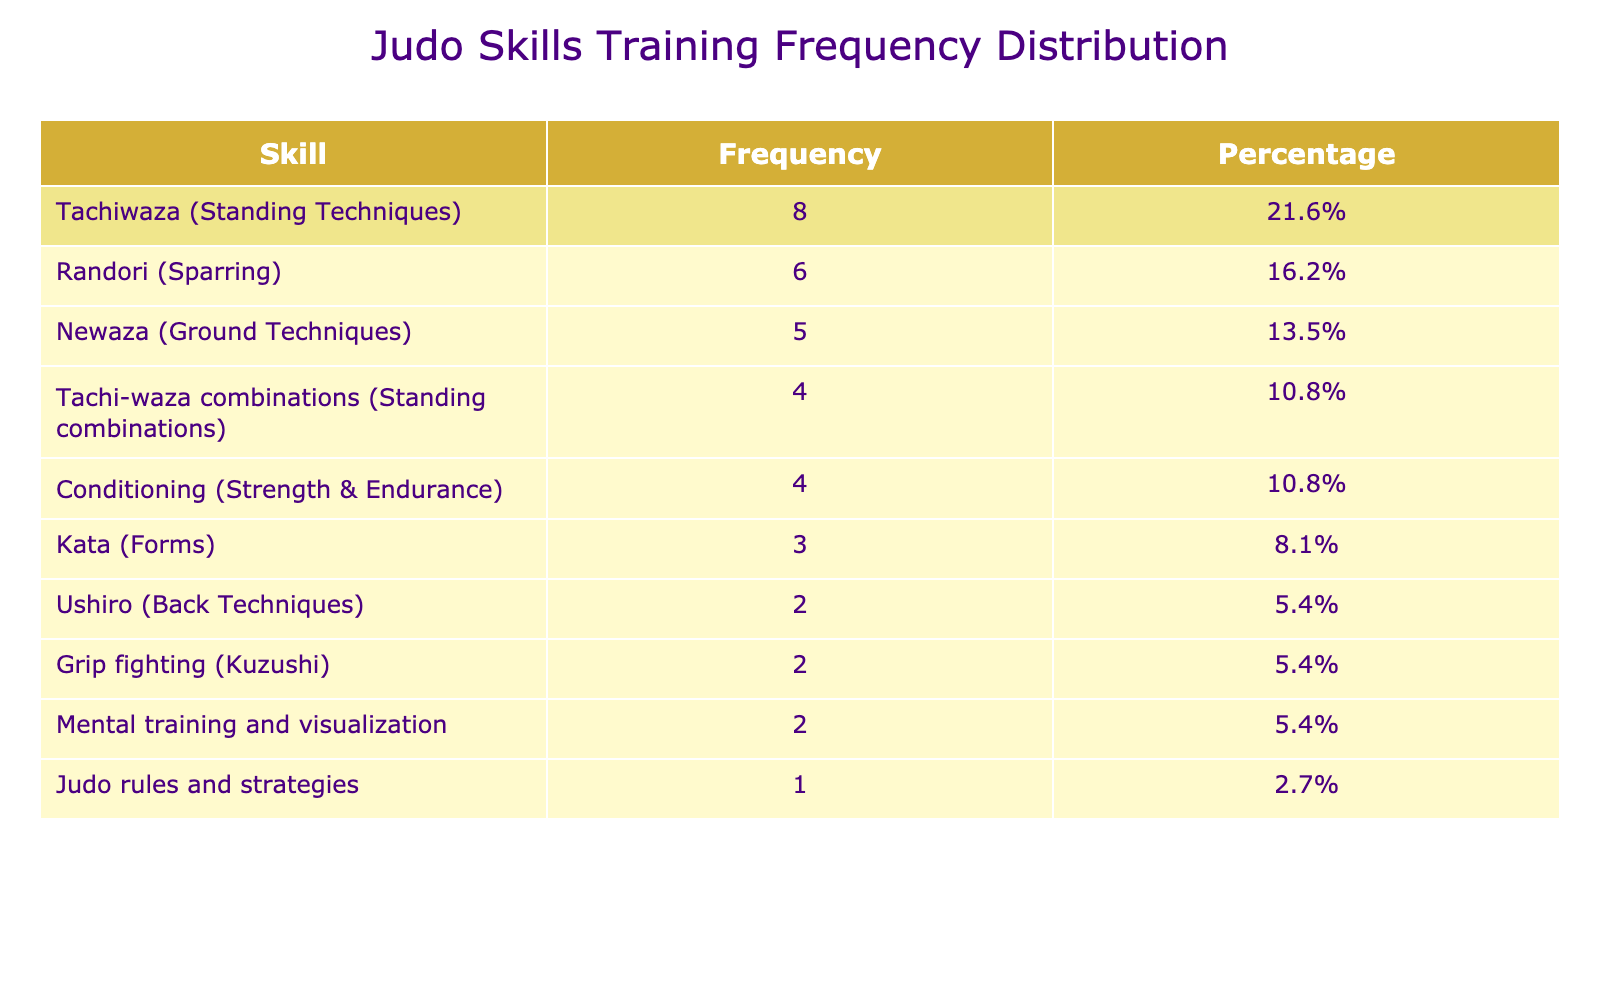What is the most time spent on a single judo skill? The table indicates that the highest frequency of training hours is for Tachiwaza (Standing Techniques) with 8 hours. This is directly observable from the frequency column of the table.
Answer: 8 hours Which skill has the least weekly training hours? The skill with the least weekly training hours is Judo rules and strategies with only 1 hour spent weekly, as noted in the frequency column of the table.
Answer: 1 hour What is the total number of hours spent on Newaza and Randori? Newaza has 5 hours, and Randori has 6 hours. Adding these together gives a total of 5 + 6 = 11 hours spent on these two skills.
Answer: 11 hours What percentage of weekly training hours is dedicated to Grip fighting? Grip fighting has 2 hours out of a total of 42 hours (5+8+3+6+2+4+2+1+4+2=42). To calculate the percentage: (2/42) * 100 = 4.76%, rounded to one decimal point gives 4.8%.
Answer: 4.8% Are there any skills that receive the same number of training hours? Yes, both Ushiro (Back Techniques) and Grip fighting (Kuzushi) each have 2 hours of training, indicating they have the same weekly training allocation.
Answer: Yes What is the average training hours per skill? To find the average, sum the total weekly training hours (42 hours) and divide by the number of skills (10). This calculation results in 42/10 = 4.2 hours on average per skill.
Answer: 4.2 hours Which skill categories could be focused on for further training hours based on this table? Skills like Kata (Forms) and Judo rules and strategies have lower hours (3 and 1 respectively) compared to others. These are areas where more focus could benefit training.
Answer: Kata and Judo rules and strategies What is the difference in training hours between Tachi-waza combinations and Mental training and visualization? Tachi-waza combinations have 4 hours while Mental training and visualization have 2 hours. The difference is therefore 4 - 2 = 2 hours more spent on Tachi-waza combinations.
Answer: 2 hours How much more time is devoted to Tachiwaza than Newaza? Tachiwaza has 8 hours compared to Newaza's 5 hours. The difference is calculated by subtracting Newaza's hours from Tachiwaza's: 8 - 5 = 3 hours.
Answer: 3 hours 